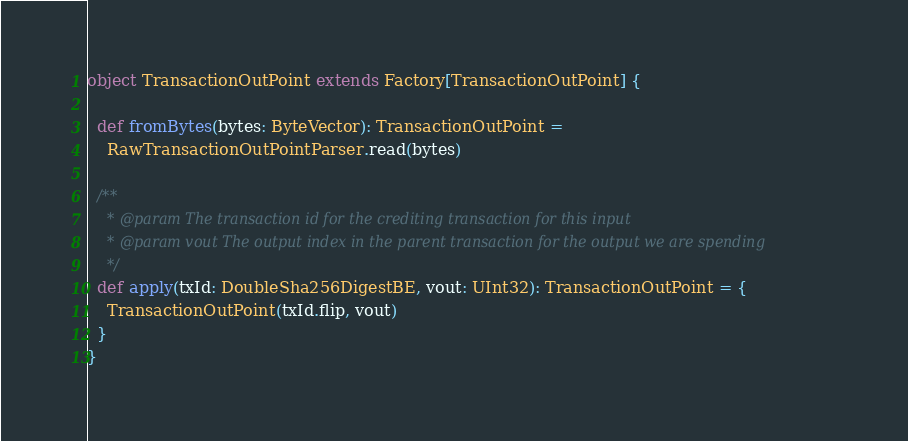Convert code to text. <code><loc_0><loc_0><loc_500><loc_500><_Scala_>object TransactionOutPoint extends Factory[TransactionOutPoint] {

  def fromBytes(bytes: ByteVector): TransactionOutPoint =
    RawTransactionOutPointParser.read(bytes)

  /**
    * @param The transaction id for the crediting transaction for this input
    * @param vout The output index in the parent transaction for the output we are spending
    */
  def apply(txId: DoubleSha256DigestBE, vout: UInt32): TransactionOutPoint = {
    TransactionOutPoint(txId.flip, vout)
  }
}
</code> 